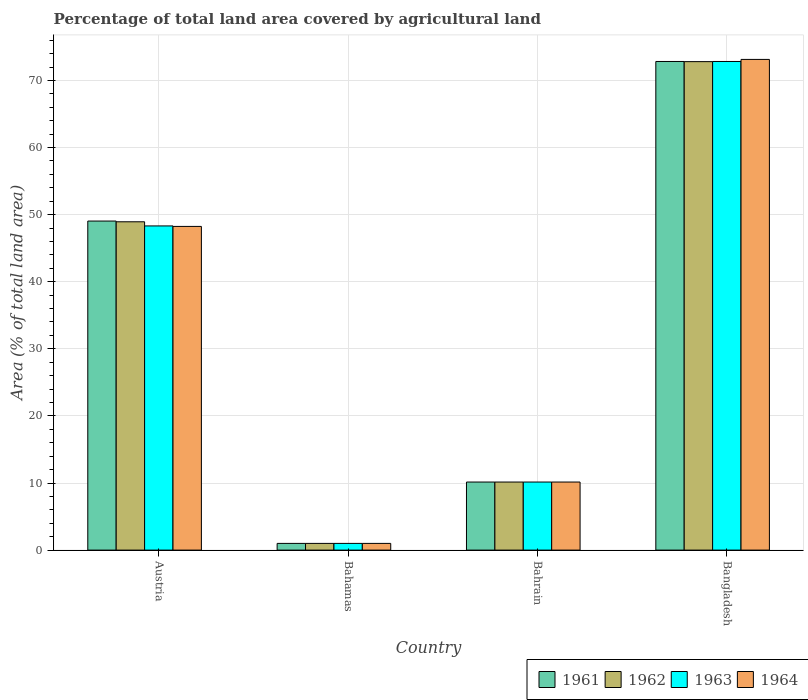How many different coloured bars are there?
Your answer should be compact. 4. Are the number of bars on each tick of the X-axis equal?
Provide a succinct answer. Yes. How many bars are there on the 4th tick from the left?
Ensure brevity in your answer.  4. How many bars are there on the 4th tick from the right?
Offer a terse response. 4. What is the label of the 1st group of bars from the left?
Make the answer very short. Austria. In how many cases, is the number of bars for a given country not equal to the number of legend labels?
Offer a very short reply. 0. What is the percentage of agricultural land in 1962 in Bahrain?
Your response must be concise. 10.14. Across all countries, what is the maximum percentage of agricultural land in 1961?
Offer a terse response. 72.83. Across all countries, what is the minimum percentage of agricultural land in 1964?
Your answer should be compact. 1. In which country was the percentage of agricultural land in 1963 maximum?
Offer a very short reply. Bangladesh. In which country was the percentage of agricultural land in 1963 minimum?
Offer a very short reply. Bahamas. What is the total percentage of agricultural land in 1961 in the graph?
Ensure brevity in your answer.  133.02. What is the difference between the percentage of agricultural land in 1964 in Bahamas and that in Bahrain?
Your answer should be very brief. -9.15. What is the difference between the percentage of agricultural land in 1964 in Bahamas and the percentage of agricultural land in 1963 in Bahrain?
Your response must be concise. -9.15. What is the average percentage of agricultural land in 1961 per country?
Your response must be concise. 33.25. What is the difference between the percentage of agricultural land of/in 1961 and percentage of agricultural land of/in 1963 in Austria?
Your response must be concise. 0.73. What is the ratio of the percentage of agricultural land in 1961 in Bahamas to that in Bahrain?
Ensure brevity in your answer.  0.1. Is the difference between the percentage of agricultural land in 1961 in Austria and Bangladesh greater than the difference between the percentage of agricultural land in 1963 in Austria and Bangladesh?
Your answer should be very brief. Yes. What is the difference between the highest and the second highest percentage of agricultural land in 1962?
Provide a succinct answer. 23.87. What is the difference between the highest and the lowest percentage of agricultural land in 1963?
Provide a succinct answer. 71.83. Is the sum of the percentage of agricultural land in 1964 in Austria and Bahrain greater than the maximum percentage of agricultural land in 1961 across all countries?
Make the answer very short. No. What does the 2nd bar from the left in Bangladesh represents?
Give a very brief answer. 1962. What does the 3rd bar from the right in Bahrain represents?
Make the answer very short. 1962. How many bars are there?
Offer a very short reply. 16. Are all the bars in the graph horizontal?
Offer a very short reply. No. Does the graph contain any zero values?
Offer a terse response. No. Does the graph contain grids?
Offer a terse response. Yes. How many legend labels are there?
Your answer should be compact. 4. How are the legend labels stacked?
Give a very brief answer. Horizontal. What is the title of the graph?
Provide a succinct answer. Percentage of total land area covered by agricultural land. What is the label or title of the X-axis?
Provide a succinct answer. Country. What is the label or title of the Y-axis?
Make the answer very short. Area (% of total land area). What is the Area (% of total land area) in 1961 in Austria?
Make the answer very short. 49.04. What is the Area (% of total land area) of 1962 in Austria?
Keep it short and to the point. 48.93. What is the Area (% of total land area) in 1963 in Austria?
Give a very brief answer. 48.32. What is the Area (% of total land area) of 1964 in Austria?
Ensure brevity in your answer.  48.24. What is the Area (% of total land area) of 1961 in Bahamas?
Provide a short and direct response. 1. What is the Area (% of total land area) of 1962 in Bahamas?
Ensure brevity in your answer.  1. What is the Area (% of total land area) of 1963 in Bahamas?
Offer a terse response. 1. What is the Area (% of total land area) of 1964 in Bahamas?
Ensure brevity in your answer.  1. What is the Area (% of total land area) of 1961 in Bahrain?
Provide a succinct answer. 10.14. What is the Area (% of total land area) of 1962 in Bahrain?
Your answer should be very brief. 10.14. What is the Area (% of total land area) of 1963 in Bahrain?
Your response must be concise. 10.14. What is the Area (% of total land area) in 1964 in Bahrain?
Your answer should be compact. 10.14. What is the Area (% of total land area) of 1961 in Bangladesh?
Your answer should be very brief. 72.83. What is the Area (% of total land area) of 1962 in Bangladesh?
Offer a very short reply. 72.8. What is the Area (% of total land area) of 1963 in Bangladesh?
Provide a short and direct response. 72.83. What is the Area (% of total land area) of 1964 in Bangladesh?
Give a very brief answer. 73.14. Across all countries, what is the maximum Area (% of total land area) of 1961?
Provide a short and direct response. 72.83. Across all countries, what is the maximum Area (% of total land area) of 1962?
Ensure brevity in your answer.  72.8. Across all countries, what is the maximum Area (% of total land area) of 1963?
Provide a succinct answer. 72.83. Across all countries, what is the maximum Area (% of total land area) of 1964?
Make the answer very short. 73.14. Across all countries, what is the minimum Area (% of total land area) in 1961?
Provide a succinct answer. 1. Across all countries, what is the minimum Area (% of total land area) in 1962?
Your answer should be compact. 1. Across all countries, what is the minimum Area (% of total land area) in 1963?
Make the answer very short. 1. Across all countries, what is the minimum Area (% of total land area) in 1964?
Your answer should be very brief. 1. What is the total Area (% of total land area) in 1961 in the graph?
Your answer should be compact. 133.02. What is the total Area (% of total land area) in 1962 in the graph?
Your answer should be compact. 132.88. What is the total Area (% of total land area) of 1963 in the graph?
Provide a succinct answer. 132.29. What is the total Area (% of total land area) in 1964 in the graph?
Your answer should be very brief. 132.52. What is the difference between the Area (% of total land area) of 1961 in Austria and that in Bahamas?
Offer a terse response. 48.04. What is the difference between the Area (% of total land area) in 1962 in Austria and that in Bahamas?
Your answer should be very brief. 47.94. What is the difference between the Area (% of total land area) in 1963 in Austria and that in Bahamas?
Give a very brief answer. 47.32. What is the difference between the Area (% of total land area) of 1964 in Austria and that in Bahamas?
Your response must be concise. 47.25. What is the difference between the Area (% of total land area) of 1961 in Austria and that in Bahrain?
Keep it short and to the point. 38.9. What is the difference between the Area (% of total land area) in 1962 in Austria and that in Bahrain?
Your answer should be compact. 38.79. What is the difference between the Area (% of total land area) of 1963 in Austria and that in Bahrain?
Offer a terse response. 38.17. What is the difference between the Area (% of total land area) in 1964 in Austria and that in Bahrain?
Offer a terse response. 38.1. What is the difference between the Area (% of total land area) of 1961 in Austria and that in Bangladesh?
Keep it short and to the point. -23.78. What is the difference between the Area (% of total land area) of 1962 in Austria and that in Bangladesh?
Your answer should be very brief. -23.87. What is the difference between the Area (% of total land area) in 1963 in Austria and that in Bangladesh?
Your answer should be very brief. -24.51. What is the difference between the Area (% of total land area) of 1964 in Austria and that in Bangladesh?
Offer a terse response. -24.89. What is the difference between the Area (% of total land area) of 1961 in Bahamas and that in Bahrain?
Keep it short and to the point. -9.15. What is the difference between the Area (% of total land area) in 1962 in Bahamas and that in Bahrain?
Ensure brevity in your answer.  -9.15. What is the difference between the Area (% of total land area) of 1963 in Bahamas and that in Bahrain?
Make the answer very short. -9.15. What is the difference between the Area (% of total land area) in 1964 in Bahamas and that in Bahrain?
Keep it short and to the point. -9.15. What is the difference between the Area (% of total land area) of 1961 in Bahamas and that in Bangladesh?
Keep it short and to the point. -71.83. What is the difference between the Area (% of total land area) in 1962 in Bahamas and that in Bangladesh?
Provide a succinct answer. -71.81. What is the difference between the Area (% of total land area) of 1963 in Bahamas and that in Bangladesh?
Offer a terse response. -71.83. What is the difference between the Area (% of total land area) in 1964 in Bahamas and that in Bangladesh?
Provide a succinct answer. -72.14. What is the difference between the Area (% of total land area) in 1961 in Bahrain and that in Bangladesh?
Provide a succinct answer. -62.68. What is the difference between the Area (% of total land area) of 1962 in Bahrain and that in Bangladesh?
Your answer should be compact. -62.66. What is the difference between the Area (% of total land area) of 1963 in Bahrain and that in Bangladesh?
Your answer should be compact. -62.68. What is the difference between the Area (% of total land area) of 1964 in Bahrain and that in Bangladesh?
Keep it short and to the point. -62.99. What is the difference between the Area (% of total land area) in 1961 in Austria and the Area (% of total land area) in 1962 in Bahamas?
Offer a terse response. 48.04. What is the difference between the Area (% of total land area) of 1961 in Austria and the Area (% of total land area) of 1963 in Bahamas?
Give a very brief answer. 48.04. What is the difference between the Area (% of total land area) of 1961 in Austria and the Area (% of total land area) of 1964 in Bahamas?
Make the answer very short. 48.04. What is the difference between the Area (% of total land area) in 1962 in Austria and the Area (% of total land area) in 1963 in Bahamas?
Your answer should be compact. 47.94. What is the difference between the Area (% of total land area) of 1962 in Austria and the Area (% of total land area) of 1964 in Bahamas?
Your answer should be compact. 47.94. What is the difference between the Area (% of total land area) of 1963 in Austria and the Area (% of total land area) of 1964 in Bahamas?
Your response must be concise. 47.32. What is the difference between the Area (% of total land area) in 1961 in Austria and the Area (% of total land area) in 1962 in Bahrain?
Keep it short and to the point. 38.9. What is the difference between the Area (% of total land area) in 1961 in Austria and the Area (% of total land area) in 1963 in Bahrain?
Keep it short and to the point. 38.9. What is the difference between the Area (% of total land area) in 1961 in Austria and the Area (% of total land area) in 1964 in Bahrain?
Your response must be concise. 38.9. What is the difference between the Area (% of total land area) in 1962 in Austria and the Area (% of total land area) in 1963 in Bahrain?
Make the answer very short. 38.79. What is the difference between the Area (% of total land area) of 1962 in Austria and the Area (% of total land area) of 1964 in Bahrain?
Give a very brief answer. 38.79. What is the difference between the Area (% of total land area) in 1963 in Austria and the Area (% of total land area) in 1964 in Bahrain?
Your response must be concise. 38.17. What is the difference between the Area (% of total land area) in 1961 in Austria and the Area (% of total land area) in 1962 in Bangladesh?
Your answer should be very brief. -23.76. What is the difference between the Area (% of total land area) in 1961 in Austria and the Area (% of total land area) in 1963 in Bangladesh?
Your response must be concise. -23.78. What is the difference between the Area (% of total land area) in 1961 in Austria and the Area (% of total land area) in 1964 in Bangladesh?
Offer a terse response. -24.09. What is the difference between the Area (% of total land area) in 1962 in Austria and the Area (% of total land area) in 1963 in Bangladesh?
Provide a short and direct response. -23.89. What is the difference between the Area (% of total land area) of 1962 in Austria and the Area (% of total land area) of 1964 in Bangladesh?
Give a very brief answer. -24.2. What is the difference between the Area (% of total land area) of 1963 in Austria and the Area (% of total land area) of 1964 in Bangladesh?
Ensure brevity in your answer.  -24.82. What is the difference between the Area (% of total land area) in 1961 in Bahamas and the Area (% of total land area) in 1962 in Bahrain?
Ensure brevity in your answer.  -9.15. What is the difference between the Area (% of total land area) in 1961 in Bahamas and the Area (% of total land area) in 1963 in Bahrain?
Offer a very short reply. -9.15. What is the difference between the Area (% of total land area) in 1961 in Bahamas and the Area (% of total land area) in 1964 in Bahrain?
Keep it short and to the point. -9.15. What is the difference between the Area (% of total land area) of 1962 in Bahamas and the Area (% of total land area) of 1963 in Bahrain?
Your response must be concise. -9.15. What is the difference between the Area (% of total land area) of 1962 in Bahamas and the Area (% of total land area) of 1964 in Bahrain?
Provide a short and direct response. -9.15. What is the difference between the Area (% of total land area) of 1963 in Bahamas and the Area (% of total land area) of 1964 in Bahrain?
Offer a very short reply. -9.15. What is the difference between the Area (% of total land area) in 1961 in Bahamas and the Area (% of total land area) in 1962 in Bangladesh?
Give a very brief answer. -71.81. What is the difference between the Area (% of total land area) in 1961 in Bahamas and the Area (% of total land area) in 1963 in Bangladesh?
Offer a terse response. -71.83. What is the difference between the Area (% of total land area) in 1961 in Bahamas and the Area (% of total land area) in 1964 in Bangladesh?
Offer a very short reply. -72.14. What is the difference between the Area (% of total land area) in 1962 in Bahamas and the Area (% of total land area) in 1963 in Bangladesh?
Ensure brevity in your answer.  -71.83. What is the difference between the Area (% of total land area) in 1962 in Bahamas and the Area (% of total land area) in 1964 in Bangladesh?
Ensure brevity in your answer.  -72.14. What is the difference between the Area (% of total land area) of 1963 in Bahamas and the Area (% of total land area) of 1964 in Bangladesh?
Keep it short and to the point. -72.14. What is the difference between the Area (% of total land area) in 1961 in Bahrain and the Area (% of total land area) in 1962 in Bangladesh?
Your answer should be compact. -62.66. What is the difference between the Area (% of total land area) of 1961 in Bahrain and the Area (% of total land area) of 1963 in Bangladesh?
Offer a very short reply. -62.68. What is the difference between the Area (% of total land area) in 1961 in Bahrain and the Area (% of total land area) in 1964 in Bangladesh?
Your response must be concise. -62.99. What is the difference between the Area (% of total land area) of 1962 in Bahrain and the Area (% of total land area) of 1963 in Bangladesh?
Your answer should be very brief. -62.68. What is the difference between the Area (% of total land area) in 1962 in Bahrain and the Area (% of total land area) in 1964 in Bangladesh?
Your answer should be very brief. -62.99. What is the difference between the Area (% of total land area) in 1963 in Bahrain and the Area (% of total land area) in 1964 in Bangladesh?
Make the answer very short. -62.99. What is the average Area (% of total land area) of 1961 per country?
Give a very brief answer. 33.25. What is the average Area (% of total land area) of 1962 per country?
Offer a terse response. 33.22. What is the average Area (% of total land area) in 1963 per country?
Make the answer very short. 33.07. What is the average Area (% of total land area) in 1964 per country?
Your answer should be compact. 33.13. What is the difference between the Area (% of total land area) of 1961 and Area (% of total land area) of 1962 in Austria?
Make the answer very short. 0.11. What is the difference between the Area (% of total land area) of 1961 and Area (% of total land area) of 1963 in Austria?
Offer a very short reply. 0.73. What is the difference between the Area (% of total land area) in 1961 and Area (% of total land area) in 1964 in Austria?
Provide a succinct answer. 0.8. What is the difference between the Area (% of total land area) in 1962 and Area (% of total land area) in 1963 in Austria?
Your response must be concise. 0.62. What is the difference between the Area (% of total land area) of 1962 and Area (% of total land area) of 1964 in Austria?
Provide a short and direct response. 0.69. What is the difference between the Area (% of total land area) in 1963 and Area (% of total land area) in 1964 in Austria?
Your answer should be compact. 0.07. What is the difference between the Area (% of total land area) in 1961 and Area (% of total land area) in 1962 in Bahamas?
Your answer should be compact. 0. What is the difference between the Area (% of total land area) of 1961 and Area (% of total land area) of 1964 in Bahamas?
Offer a very short reply. 0. What is the difference between the Area (% of total land area) in 1962 and Area (% of total land area) in 1964 in Bahamas?
Give a very brief answer. 0. What is the difference between the Area (% of total land area) in 1961 and Area (% of total land area) in 1963 in Bahrain?
Your answer should be very brief. 0. What is the difference between the Area (% of total land area) of 1961 and Area (% of total land area) of 1964 in Bahrain?
Give a very brief answer. 0. What is the difference between the Area (% of total land area) of 1962 and Area (% of total land area) of 1963 in Bahrain?
Offer a terse response. 0. What is the difference between the Area (% of total land area) of 1961 and Area (% of total land area) of 1962 in Bangladesh?
Provide a succinct answer. 0.02. What is the difference between the Area (% of total land area) in 1961 and Area (% of total land area) in 1963 in Bangladesh?
Provide a short and direct response. 0. What is the difference between the Area (% of total land area) in 1961 and Area (% of total land area) in 1964 in Bangladesh?
Provide a short and direct response. -0.31. What is the difference between the Area (% of total land area) in 1962 and Area (% of total land area) in 1963 in Bangladesh?
Offer a terse response. -0.02. What is the difference between the Area (% of total land area) in 1962 and Area (% of total land area) in 1964 in Bangladesh?
Your response must be concise. -0.33. What is the difference between the Area (% of total land area) of 1963 and Area (% of total land area) of 1964 in Bangladesh?
Ensure brevity in your answer.  -0.31. What is the ratio of the Area (% of total land area) of 1961 in Austria to that in Bahamas?
Ensure brevity in your answer.  49.09. What is the ratio of the Area (% of total land area) of 1962 in Austria to that in Bahamas?
Provide a short and direct response. 48.98. What is the ratio of the Area (% of total land area) of 1963 in Austria to that in Bahamas?
Ensure brevity in your answer.  48.37. What is the ratio of the Area (% of total land area) in 1964 in Austria to that in Bahamas?
Give a very brief answer. 48.29. What is the ratio of the Area (% of total land area) in 1961 in Austria to that in Bahrain?
Make the answer very short. 4.83. What is the ratio of the Area (% of total land area) in 1962 in Austria to that in Bahrain?
Your answer should be compact. 4.82. What is the ratio of the Area (% of total land area) in 1963 in Austria to that in Bahrain?
Provide a succinct answer. 4.76. What is the ratio of the Area (% of total land area) of 1964 in Austria to that in Bahrain?
Your answer should be compact. 4.76. What is the ratio of the Area (% of total land area) of 1961 in Austria to that in Bangladesh?
Your answer should be very brief. 0.67. What is the ratio of the Area (% of total land area) of 1962 in Austria to that in Bangladesh?
Your answer should be very brief. 0.67. What is the ratio of the Area (% of total land area) of 1963 in Austria to that in Bangladesh?
Provide a short and direct response. 0.66. What is the ratio of the Area (% of total land area) of 1964 in Austria to that in Bangladesh?
Your response must be concise. 0.66. What is the ratio of the Area (% of total land area) in 1961 in Bahamas to that in Bahrain?
Give a very brief answer. 0.1. What is the ratio of the Area (% of total land area) of 1962 in Bahamas to that in Bahrain?
Offer a very short reply. 0.1. What is the ratio of the Area (% of total land area) of 1963 in Bahamas to that in Bahrain?
Provide a short and direct response. 0.1. What is the ratio of the Area (% of total land area) of 1964 in Bahamas to that in Bahrain?
Your answer should be compact. 0.1. What is the ratio of the Area (% of total land area) in 1961 in Bahamas to that in Bangladesh?
Provide a short and direct response. 0.01. What is the ratio of the Area (% of total land area) in 1962 in Bahamas to that in Bangladesh?
Your response must be concise. 0.01. What is the ratio of the Area (% of total land area) in 1963 in Bahamas to that in Bangladesh?
Your answer should be very brief. 0.01. What is the ratio of the Area (% of total land area) of 1964 in Bahamas to that in Bangladesh?
Offer a very short reply. 0.01. What is the ratio of the Area (% of total land area) of 1961 in Bahrain to that in Bangladesh?
Offer a terse response. 0.14. What is the ratio of the Area (% of total land area) of 1962 in Bahrain to that in Bangladesh?
Keep it short and to the point. 0.14. What is the ratio of the Area (% of total land area) of 1963 in Bahrain to that in Bangladesh?
Provide a short and direct response. 0.14. What is the ratio of the Area (% of total land area) in 1964 in Bahrain to that in Bangladesh?
Offer a very short reply. 0.14. What is the difference between the highest and the second highest Area (% of total land area) in 1961?
Your response must be concise. 23.78. What is the difference between the highest and the second highest Area (% of total land area) in 1962?
Give a very brief answer. 23.87. What is the difference between the highest and the second highest Area (% of total land area) of 1963?
Provide a succinct answer. 24.51. What is the difference between the highest and the second highest Area (% of total land area) of 1964?
Give a very brief answer. 24.89. What is the difference between the highest and the lowest Area (% of total land area) in 1961?
Provide a short and direct response. 71.83. What is the difference between the highest and the lowest Area (% of total land area) of 1962?
Your answer should be very brief. 71.81. What is the difference between the highest and the lowest Area (% of total land area) of 1963?
Give a very brief answer. 71.83. What is the difference between the highest and the lowest Area (% of total land area) of 1964?
Provide a succinct answer. 72.14. 